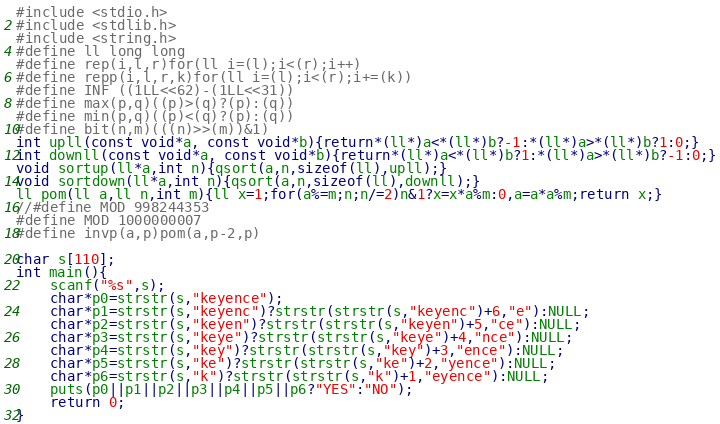Convert code to text. <code><loc_0><loc_0><loc_500><loc_500><_C_>#include <stdio.h>
#include <stdlib.h>
#include <string.h>
#define ll long long
#define rep(i,l,r)for(ll i=(l);i<(r);i++)
#define repp(i,l,r,k)for(ll i=(l);i<(r);i+=(k))
#define INF ((1LL<<62)-(1LL<<31))
#define max(p,q)((p)>(q)?(p):(q))
#define min(p,q)((p)<(q)?(p):(q))
#define bit(n,m)(((n)>>(m))&1)
int upll(const void*a, const void*b){return*(ll*)a<*(ll*)b?-1:*(ll*)a>*(ll*)b?1:0;}
int downll(const void*a, const void*b){return*(ll*)a<*(ll*)b?1:*(ll*)a>*(ll*)b?-1:0;}
void sortup(ll*a,int n){qsort(a,n,sizeof(ll),upll);}
void sortdown(ll*a,int n){qsort(a,n,sizeof(ll),downll);}
ll pom(ll a,ll n,int m){ll x=1;for(a%=m;n;n/=2)n&1?x=x*a%m:0,a=a*a%m;return x;}
//#define MOD 998244353
#define MOD 1000000007
#define invp(a,p)pom(a,p-2,p)

char s[110];
int main(){
	scanf("%s",s);
	char*p0=strstr(s,"keyence");
	char*p1=strstr(s,"keyenc")?strstr(strstr(s,"keyenc")+6,"e"):NULL;
	char*p2=strstr(s,"keyen")?strstr(strstr(s,"keyen")+5,"ce"):NULL;
	char*p3=strstr(s,"keye")?strstr(strstr(s,"keye")+4,"nce"):NULL;
	char*p4=strstr(s,"key")?strstr(strstr(s,"key")+3,"ence"):NULL;
	char*p5=strstr(s,"ke")?strstr(strstr(s,"ke")+2,"yence"):NULL;
	char*p6=strstr(s,"k")?strstr(strstr(s,"k")+1,"eyence"):NULL;
	puts(p0||p1||p2||p3||p4||p5||p6?"YES":"NO");
	return 0;
}</code> 